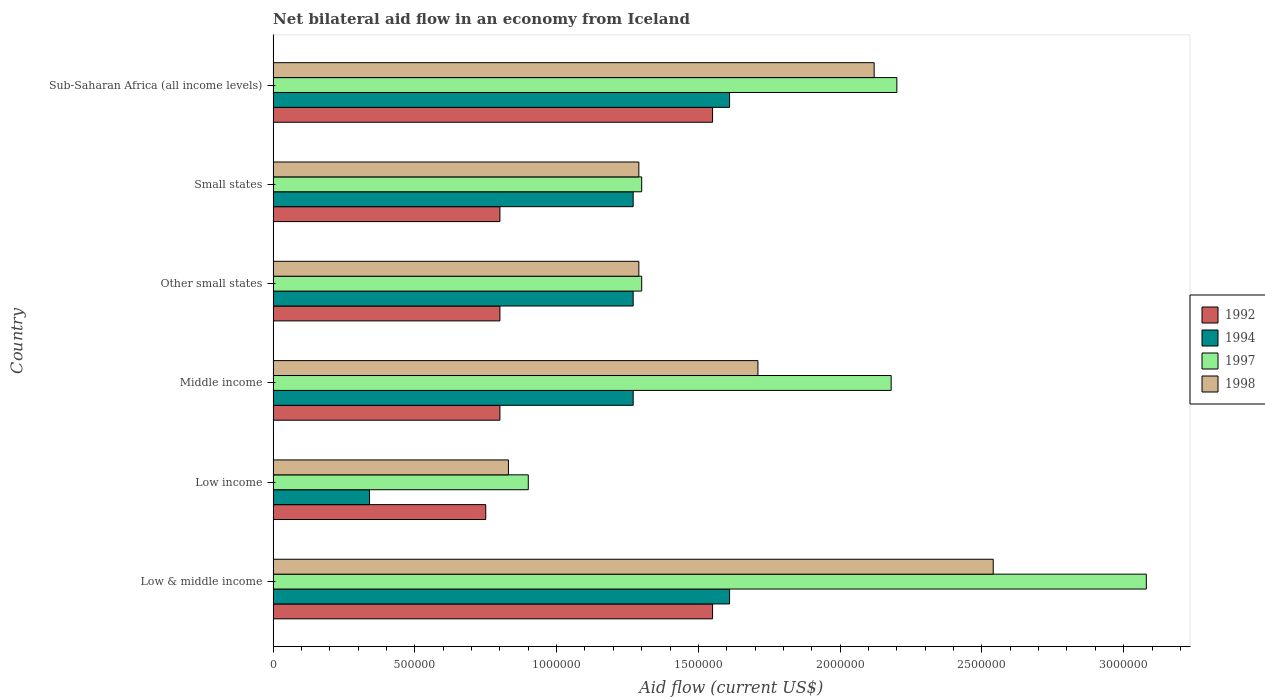How many bars are there on the 3rd tick from the top?
Your response must be concise. 4. How many bars are there on the 2nd tick from the bottom?
Make the answer very short. 4. What is the label of the 6th group of bars from the top?
Your response must be concise. Low & middle income. What is the net bilateral aid flow in 1998 in Low income?
Provide a succinct answer. 8.30e+05. Across all countries, what is the maximum net bilateral aid flow in 1998?
Give a very brief answer. 2.54e+06. In which country was the net bilateral aid flow in 1992 minimum?
Provide a short and direct response. Low income. What is the total net bilateral aid flow in 1997 in the graph?
Provide a short and direct response. 1.10e+07. What is the difference between the net bilateral aid flow in 1994 in Low & middle income and that in Other small states?
Give a very brief answer. 3.40e+05. What is the difference between the net bilateral aid flow in 1998 in Other small states and the net bilateral aid flow in 1994 in Low income?
Offer a very short reply. 9.50e+05. What is the average net bilateral aid flow in 1998 per country?
Keep it short and to the point. 1.63e+06. What is the difference between the net bilateral aid flow in 1998 and net bilateral aid flow in 1992 in Sub-Saharan Africa (all income levels)?
Offer a terse response. 5.70e+05. In how many countries, is the net bilateral aid flow in 1992 greater than 500000 US$?
Keep it short and to the point. 6. Is the net bilateral aid flow in 1994 in Low income less than that in Other small states?
Your answer should be compact. Yes. Is the difference between the net bilateral aid flow in 1998 in Low income and Other small states greater than the difference between the net bilateral aid flow in 1992 in Low income and Other small states?
Keep it short and to the point. No. What is the difference between the highest and the second highest net bilateral aid flow in 1998?
Provide a short and direct response. 4.20e+05. What is the difference between the highest and the lowest net bilateral aid flow in 1998?
Provide a short and direct response. 1.71e+06. In how many countries, is the net bilateral aid flow in 1998 greater than the average net bilateral aid flow in 1998 taken over all countries?
Offer a very short reply. 3. Is the sum of the net bilateral aid flow in 1998 in Low income and Sub-Saharan Africa (all income levels) greater than the maximum net bilateral aid flow in 1994 across all countries?
Provide a succinct answer. Yes. Is it the case that in every country, the sum of the net bilateral aid flow in 1994 and net bilateral aid flow in 1997 is greater than the sum of net bilateral aid flow in 1992 and net bilateral aid flow in 1998?
Your answer should be compact. No. What does the 1st bar from the bottom in Low & middle income represents?
Make the answer very short. 1992. Is it the case that in every country, the sum of the net bilateral aid flow in 1994 and net bilateral aid flow in 1992 is greater than the net bilateral aid flow in 1997?
Offer a very short reply. No. How many bars are there?
Your answer should be compact. 24. Are all the bars in the graph horizontal?
Make the answer very short. Yes. Are the values on the major ticks of X-axis written in scientific E-notation?
Make the answer very short. No. Does the graph contain any zero values?
Your response must be concise. No. Where does the legend appear in the graph?
Give a very brief answer. Center right. How many legend labels are there?
Your answer should be very brief. 4. How are the legend labels stacked?
Provide a short and direct response. Vertical. What is the title of the graph?
Keep it short and to the point. Net bilateral aid flow in an economy from Iceland. Does "2007" appear as one of the legend labels in the graph?
Your response must be concise. No. What is the label or title of the Y-axis?
Your response must be concise. Country. What is the Aid flow (current US$) of 1992 in Low & middle income?
Your answer should be compact. 1.55e+06. What is the Aid flow (current US$) of 1994 in Low & middle income?
Offer a very short reply. 1.61e+06. What is the Aid flow (current US$) in 1997 in Low & middle income?
Your answer should be compact. 3.08e+06. What is the Aid flow (current US$) in 1998 in Low & middle income?
Give a very brief answer. 2.54e+06. What is the Aid flow (current US$) in 1992 in Low income?
Your response must be concise. 7.50e+05. What is the Aid flow (current US$) of 1998 in Low income?
Provide a short and direct response. 8.30e+05. What is the Aid flow (current US$) of 1994 in Middle income?
Offer a very short reply. 1.27e+06. What is the Aid flow (current US$) of 1997 in Middle income?
Provide a short and direct response. 2.18e+06. What is the Aid flow (current US$) of 1998 in Middle income?
Offer a very short reply. 1.71e+06. What is the Aid flow (current US$) in 1994 in Other small states?
Offer a very short reply. 1.27e+06. What is the Aid flow (current US$) in 1997 in Other small states?
Your answer should be compact. 1.30e+06. What is the Aid flow (current US$) of 1998 in Other small states?
Offer a terse response. 1.29e+06. What is the Aid flow (current US$) of 1994 in Small states?
Offer a terse response. 1.27e+06. What is the Aid flow (current US$) of 1997 in Small states?
Keep it short and to the point. 1.30e+06. What is the Aid flow (current US$) in 1998 in Small states?
Give a very brief answer. 1.29e+06. What is the Aid flow (current US$) in 1992 in Sub-Saharan Africa (all income levels)?
Your answer should be compact. 1.55e+06. What is the Aid flow (current US$) of 1994 in Sub-Saharan Africa (all income levels)?
Keep it short and to the point. 1.61e+06. What is the Aid flow (current US$) in 1997 in Sub-Saharan Africa (all income levels)?
Provide a short and direct response. 2.20e+06. What is the Aid flow (current US$) in 1998 in Sub-Saharan Africa (all income levels)?
Your answer should be very brief. 2.12e+06. Across all countries, what is the maximum Aid flow (current US$) of 1992?
Provide a short and direct response. 1.55e+06. Across all countries, what is the maximum Aid flow (current US$) of 1994?
Provide a succinct answer. 1.61e+06. Across all countries, what is the maximum Aid flow (current US$) of 1997?
Offer a very short reply. 3.08e+06. Across all countries, what is the maximum Aid flow (current US$) of 1998?
Your answer should be very brief. 2.54e+06. Across all countries, what is the minimum Aid flow (current US$) in 1992?
Make the answer very short. 7.50e+05. Across all countries, what is the minimum Aid flow (current US$) in 1994?
Your answer should be compact. 3.40e+05. Across all countries, what is the minimum Aid flow (current US$) of 1998?
Keep it short and to the point. 8.30e+05. What is the total Aid flow (current US$) in 1992 in the graph?
Your answer should be very brief. 6.25e+06. What is the total Aid flow (current US$) in 1994 in the graph?
Ensure brevity in your answer.  7.37e+06. What is the total Aid flow (current US$) of 1997 in the graph?
Your answer should be very brief. 1.10e+07. What is the total Aid flow (current US$) in 1998 in the graph?
Provide a short and direct response. 9.78e+06. What is the difference between the Aid flow (current US$) in 1994 in Low & middle income and that in Low income?
Your response must be concise. 1.27e+06. What is the difference between the Aid flow (current US$) of 1997 in Low & middle income and that in Low income?
Your response must be concise. 2.18e+06. What is the difference between the Aid flow (current US$) of 1998 in Low & middle income and that in Low income?
Ensure brevity in your answer.  1.71e+06. What is the difference between the Aid flow (current US$) in 1992 in Low & middle income and that in Middle income?
Your answer should be compact. 7.50e+05. What is the difference between the Aid flow (current US$) in 1998 in Low & middle income and that in Middle income?
Give a very brief answer. 8.30e+05. What is the difference between the Aid flow (current US$) in 1992 in Low & middle income and that in Other small states?
Provide a short and direct response. 7.50e+05. What is the difference between the Aid flow (current US$) of 1997 in Low & middle income and that in Other small states?
Your answer should be very brief. 1.78e+06. What is the difference between the Aid flow (current US$) in 1998 in Low & middle income and that in Other small states?
Your response must be concise. 1.25e+06. What is the difference between the Aid flow (current US$) in 1992 in Low & middle income and that in Small states?
Give a very brief answer. 7.50e+05. What is the difference between the Aid flow (current US$) of 1997 in Low & middle income and that in Small states?
Provide a short and direct response. 1.78e+06. What is the difference between the Aid flow (current US$) in 1998 in Low & middle income and that in Small states?
Your answer should be very brief. 1.25e+06. What is the difference between the Aid flow (current US$) in 1994 in Low & middle income and that in Sub-Saharan Africa (all income levels)?
Give a very brief answer. 0. What is the difference between the Aid flow (current US$) in 1997 in Low & middle income and that in Sub-Saharan Africa (all income levels)?
Provide a succinct answer. 8.80e+05. What is the difference between the Aid flow (current US$) of 1994 in Low income and that in Middle income?
Offer a very short reply. -9.30e+05. What is the difference between the Aid flow (current US$) in 1997 in Low income and that in Middle income?
Your response must be concise. -1.28e+06. What is the difference between the Aid flow (current US$) of 1998 in Low income and that in Middle income?
Give a very brief answer. -8.80e+05. What is the difference between the Aid flow (current US$) in 1992 in Low income and that in Other small states?
Make the answer very short. -5.00e+04. What is the difference between the Aid flow (current US$) of 1994 in Low income and that in Other small states?
Your answer should be compact. -9.30e+05. What is the difference between the Aid flow (current US$) in 1997 in Low income and that in Other small states?
Make the answer very short. -4.00e+05. What is the difference between the Aid flow (current US$) in 1998 in Low income and that in Other small states?
Keep it short and to the point. -4.60e+05. What is the difference between the Aid flow (current US$) in 1994 in Low income and that in Small states?
Provide a succinct answer. -9.30e+05. What is the difference between the Aid flow (current US$) of 1997 in Low income and that in Small states?
Provide a succinct answer. -4.00e+05. What is the difference between the Aid flow (current US$) of 1998 in Low income and that in Small states?
Your answer should be compact. -4.60e+05. What is the difference between the Aid flow (current US$) in 1992 in Low income and that in Sub-Saharan Africa (all income levels)?
Provide a short and direct response. -8.00e+05. What is the difference between the Aid flow (current US$) in 1994 in Low income and that in Sub-Saharan Africa (all income levels)?
Your answer should be compact. -1.27e+06. What is the difference between the Aid flow (current US$) in 1997 in Low income and that in Sub-Saharan Africa (all income levels)?
Offer a very short reply. -1.30e+06. What is the difference between the Aid flow (current US$) of 1998 in Low income and that in Sub-Saharan Africa (all income levels)?
Offer a very short reply. -1.29e+06. What is the difference between the Aid flow (current US$) of 1992 in Middle income and that in Other small states?
Provide a succinct answer. 0. What is the difference between the Aid flow (current US$) in 1997 in Middle income and that in Other small states?
Ensure brevity in your answer.  8.80e+05. What is the difference between the Aid flow (current US$) in 1997 in Middle income and that in Small states?
Provide a short and direct response. 8.80e+05. What is the difference between the Aid flow (current US$) of 1992 in Middle income and that in Sub-Saharan Africa (all income levels)?
Offer a terse response. -7.50e+05. What is the difference between the Aid flow (current US$) in 1998 in Middle income and that in Sub-Saharan Africa (all income levels)?
Make the answer very short. -4.10e+05. What is the difference between the Aid flow (current US$) in 1994 in Other small states and that in Small states?
Provide a short and direct response. 0. What is the difference between the Aid flow (current US$) of 1997 in Other small states and that in Small states?
Offer a very short reply. 0. What is the difference between the Aid flow (current US$) of 1992 in Other small states and that in Sub-Saharan Africa (all income levels)?
Offer a terse response. -7.50e+05. What is the difference between the Aid flow (current US$) in 1997 in Other small states and that in Sub-Saharan Africa (all income levels)?
Your answer should be very brief. -9.00e+05. What is the difference between the Aid flow (current US$) of 1998 in Other small states and that in Sub-Saharan Africa (all income levels)?
Make the answer very short. -8.30e+05. What is the difference between the Aid flow (current US$) in 1992 in Small states and that in Sub-Saharan Africa (all income levels)?
Give a very brief answer. -7.50e+05. What is the difference between the Aid flow (current US$) of 1997 in Small states and that in Sub-Saharan Africa (all income levels)?
Provide a short and direct response. -9.00e+05. What is the difference between the Aid flow (current US$) in 1998 in Small states and that in Sub-Saharan Africa (all income levels)?
Ensure brevity in your answer.  -8.30e+05. What is the difference between the Aid flow (current US$) in 1992 in Low & middle income and the Aid flow (current US$) in 1994 in Low income?
Make the answer very short. 1.21e+06. What is the difference between the Aid flow (current US$) of 1992 in Low & middle income and the Aid flow (current US$) of 1997 in Low income?
Give a very brief answer. 6.50e+05. What is the difference between the Aid flow (current US$) in 1992 in Low & middle income and the Aid flow (current US$) in 1998 in Low income?
Make the answer very short. 7.20e+05. What is the difference between the Aid flow (current US$) of 1994 in Low & middle income and the Aid flow (current US$) of 1997 in Low income?
Make the answer very short. 7.10e+05. What is the difference between the Aid flow (current US$) in 1994 in Low & middle income and the Aid flow (current US$) in 1998 in Low income?
Provide a succinct answer. 7.80e+05. What is the difference between the Aid flow (current US$) in 1997 in Low & middle income and the Aid flow (current US$) in 1998 in Low income?
Offer a terse response. 2.25e+06. What is the difference between the Aid flow (current US$) in 1992 in Low & middle income and the Aid flow (current US$) in 1997 in Middle income?
Your answer should be compact. -6.30e+05. What is the difference between the Aid flow (current US$) in 1994 in Low & middle income and the Aid flow (current US$) in 1997 in Middle income?
Your answer should be very brief. -5.70e+05. What is the difference between the Aid flow (current US$) in 1997 in Low & middle income and the Aid flow (current US$) in 1998 in Middle income?
Your answer should be compact. 1.37e+06. What is the difference between the Aid flow (current US$) in 1992 in Low & middle income and the Aid flow (current US$) in 1997 in Other small states?
Keep it short and to the point. 2.50e+05. What is the difference between the Aid flow (current US$) of 1992 in Low & middle income and the Aid flow (current US$) of 1998 in Other small states?
Provide a succinct answer. 2.60e+05. What is the difference between the Aid flow (current US$) of 1994 in Low & middle income and the Aid flow (current US$) of 1997 in Other small states?
Ensure brevity in your answer.  3.10e+05. What is the difference between the Aid flow (current US$) of 1997 in Low & middle income and the Aid flow (current US$) of 1998 in Other small states?
Your answer should be very brief. 1.79e+06. What is the difference between the Aid flow (current US$) of 1992 in Low & middle income and the Aid flow (current US$) of 1994 in Small states?
Provide a succinct answer. 2.80e+05. What is the difference between the Aid flow (current US$) of 1992 in Low & middle income and the Aid flow (current US$) of 1997 in Small states?
Offer a terse response. 2.50e+05. What is the difference between the Aid flow (current US$) of 1992 in Low & middle income and the Aid flow (current US$) of 1998 in Small states?
Provide a succinct answer. 2.60e+05. What is the difference between the Aid flow (current US$) of 1994 in Low & middle income and the Aid flow (current US$) of 1997 in Small states?
Give a very brief answer. 3.10e+05. What is the difference between the Aid flow (current US$) in 1994 in Low & middle income and the Aid flow (current US$) in 1998 in Small states?
Your response must be concise. 3.20e+05. What is the difference between the Aid flow (current US$) of 1997 in Low & middle income and the Aid flow (current US$) of 1998 in Small states?
Your response must be concise. 1.79e+06. What is the difference between the Aid flow (current US$) of 1992 in Low & middle income and the Aid flow (current US$) of 1994 in Sub-Saharan Africa (all income levels)?
Give a very brief answer. -6.00e+04. What is the difference between the Aid flow (current US$) in 1992 in Low & middle income and the Aid flow (current US$) in 1997 in Sub-Saharan Africa (all income levels)?
Give a very brief answer. -6.50e+05. What is the difference between the Aid flow (current US$) in 1992 in Low & middle income and the Aid flow (current US$) in 1998 in Sub-Saharan Africa (all income levels)?
Keep it short and to the point. -5.70e+05. What is the difference between the Aid flow (current US$) of 1994 in Low & middle income and the Aid flow (current US$) of 1997 in Sub-Saharan Africa (all income levels)?
Your answer should be compact. -5.90e+05. What is the difference between the Aid flow (current US$) of 1994 in Low & middle income and the Aid flow (current US$) of 1998 in Sub-Saharan Africa (all income levels)?
Your answer should be very brief. -5.10e+05. What is the difference between the Aid flow (current US$) of 1997 in Low & middle income and the Aid flow (current US$) of 1998 in Sub-Saharan Africa (all income levels)?
Offer a terse response. 9.60e+05. What is the difference between the Aid flow (current US$) in 1992 in Low income and the Aid flow (current US$) in 1994 in Middle income?
Ensure brevity in your answer.  -5.20e+05. What is the difference between the Aid flow (current US$) of 1992 in Low income and the Aid flow (current US$) of 1997 in Middle income?
Provide a short and direct response. -1.43e+06. What is the difference between the Aid flow (current US$) in 1992 in Low income and the Aid flow (current US$) in 1998 in Middle income?
Offer a very short reply. -9.60e+05. What is the difference between the Aid flow (current US$) in 1994 in Low income and the Aid flow (current US$) in 1997 in Middle income?
Offer a terse response. -1.84e+06. What is the difference between the Aid flow (current US$) in 1994 in Low income and the Aid flow (current US$) in 1998 in Middle income?
Provide a succinct answer. -1.37e+06. What is the difference between the Aid flow (current US$) of 1997 in Low income and the Aid flow (current US$) of 1998 in Middle income?
Your response must be concise. -8.10e+05. What is the difference between the Aid flow (current US$) of 1992 in Low income and the Aid flow (current US$) of 1994 in Other small states?
Your response must be concise. -5.20e+05. What is the difference between the Aid flow (current US$) of 1992 in Low income and the Aid flow (current US$) of 1997 in Other small states?
Make the answer very short. -5.50e+05. What is the difference between the Aid flow (current US$) of 1992 in Low income and the Aid flow (current US$) of 1998 in Other small states?
Ensure brevity in your answer.  -5.40e+05. What is the difference between the Aid flow (current US$) in 1994 in Low income and the Aid flow (current US$) in 1997 in Other small states?
Provide a succinct answer. -9.60e+05. What is the difference between the Aid flow (current US$) of 1994 in Low income and the Aid flow (current US$) of 1998 in Other small states?
Your answer should be compact. -9.50e+05. What is the difference between the Aid flow (current US$) of 1997 in Low income and the Aid flow (current US$) of 1998 in Other small states?
Offer a terse response. -3.90e+05. What is the difference between the Aid flow (current US$) in 1992 in Low income and the Aid flow (current US$) in 1994 in Small states?
Your answer should be compact. -5.20e+05. What is the difference between the Aid flow (current US$) of 1992 in Low income and the Aid flow (current US$) of 1997 in Small states?
Your answer should be compact. -5.50e+05. What is the difference between the Aid flow (current US$) of 1992 in Low income and the Aid flow (current US$) of 1998 in Small states?
Make the answer very short. -5.40e+05. What is the difference between the Aid flow (current US$) of 1994 in Low income and the Aid flow (current US$) of 1997 in Small states?
Provide a succinct answer. -9.60e+05. What is the difference between the Aid flow (current US$) in 1994 in Low income and the Aid flow (current US$) in 1998 in Small states?
Offer a terse response. -9.50e+05. What is the difference between the Aid flow (current US$) of 1997 in Low income and the Aid flow (current US$) of 1998 in Small states?
Your answer should be very brief. -3.90e+05. What is the difference between the Aid flow (current US$) in 1992 in Low income and the Aid flow (current US$) in 1994 in Sub-Saharan Africa (all income levels)?
Keep it short and to the point. -8.60e+05. What is the difference between the Aid flow (current US$) of 1992 in Low income and the Aid flow (current US$) of 1997 in Sub-Saharan Africa (all income levels)?
Your answer should be compact. -1.45e+06. What is the difference between the Aid flow (current US$) of 1992 in Low income and the Aid flow (current US$) of 1998 in Sub-Saharan Africa (all income levels)?
Provide a succinct answer. -1.37e+06. What is the difference between the Aid flow (current US$) in 1994 in Low income and the Aid flow (current US$) in 1997 in Sub-Saharan Africa (all income levels)?
Provide a short and direct response. -1.86e+06. What is the difference between the Aid flow (current US$) of 1994 in Low income and the Aid flow (current US$) of 1998 in Sub-Saharan Africa (all income levels)?
Ensure brevity in your answer.  -1.78e+06. What is the difference between the Aid flow (current US$) in 1997 in Low income and the Aid flow (current US$) in 1998 in Sub-Saharan Africa (all income levels)?
Your response must be concise. -1.22e+06. What is the difference between the Aid flow (current US$) of 1992 in Middle income and the Aid flow (current US$) of 1994 in Other small states?
Make the answer very short. -4.70e+05. What is the difference between the Aid flow (current US$) in 1992 in Middle income and the Aid flow (current US$) in 1997 in Other small states?
Provide a succinct answer. -5.00e+05. What is the difference between the Aid flow (current US$) of 1992 in Middle income and the Aid flow (current US$) of 1998 in Other small states?
Provide a succinct answer. -4.90e+05. What is the difference between the Aid flow (current US$) of 1994 in Middle income and the Aid flow (current US$) of 1997 in Other small states?
Your response must be concise. -3.00e+04. What is the difference between the Aid flow (current US$) of 1994 in Middle income and the Aid flow (current US$) of 1998 in Other small states?
Ensure brevity in your answer.  -2.00e+04. What is the difference between the Aid flow (current US$) in 1997 in Middle income and the Aid flow (current US$) in 1998 in Other small states?
Give a very brief answer. 8.90e+05. What is the difference between the Aid flow (current US$) of 1992 in Middle income and the Aid flow (current US$) of 1994 in Small states?
Provide a succinct answer. -4.70e+05. What is the difference between the Aid flow (current US$) in 1992 in Middle income and the Aid flow (current US$) in 1997 in Small states?
Keep it short and to the point. -5.00e+05. What is the difference between the Aid flow (current US$) of 1992 in Middle income and the Aid flow (current US$) of 1998 in Small states?
Your answer should be compact. -4.90e+05. What is the difference between the Aid flow (current US$) of 1994 in Middle income and the Aid flow (current US$) of 1997 in Small states?
Give a very brief answer. -3.00e+04. What is the difference between the Aid flow (current US$) in 1994 in Middle income and the Aid flow (current US$) in 1998 in Small states?
Offer a terse response. -2.00e+04. What is the difference between the Aid flow (current US$) of 1997 in Middle income and the Aid flow (current US$) of 1998 in Small states?
Make the answer very short. 8.90e+05. What is the difference between the Aid flow (current US$) in 1992 in Middle income and the Aid flow (current US$) in 1994 in Sub-Saharan Africa (all income levels)?
Provide a short and direct response. -8.10e+05. What is the difference between the Aid flow (current US$) of 1992 in Middle income and the Aid flow (current US$) of 1997 in Sub-Saharan Africa (all income levels)?
Offer a very short reply. -1.40e+06. What is the difference between the Aid flow (current US$) in 1992 in Middle income and the Aid flow (current US$) in 1998 in Sub-Saharan Africa (all income levels)?
Provide a short and direct response. -1.32e+06. What is the difference between the Aid flow (current US$) of 1994 in Middle income and the Aid flow (current US$) of 1997 in Sub-Saharan Africa (all income levels)?
Offer a terse response. -9.30e+05. What is the difference between the Aid flow (current US$) in 1994 in Middle income and the Aid flow (current US$) in 1998 in Sub-Saharan Africa (all income levels)?
Your answer should be very brief. -8.50e+05. What is the difference between the Aid flow (current US$) of 1992 in Other small states and the Aid flow (current US$) of 1994 in Small states?
Your answer should be very brief. -4.70e+05. What is the difference between the Aid flow (current US$) in 1992 in Other small states and the Aid flow (current US$) in 1997 in Small states?
Make the answer very short. -5.00e+05. What is the difference between the Aid flow (current US$) in 1992 in Other small states and the Aid flow (current US$) in 1998 in Small states?
Your answer should be compact. -4.90e+05. What is the difference between the Aid flow (current US$) in 1994 in Other small states and the Aid flow (current US$) in 1997 in Small states?
Your response must be concise. -3.00e+04. What is the difference between the Aid flow (current US$) of 1997 in Other small states and the Aid flow (current US$) of 1998 in Small states?
Offer a very short reply. 10000. What is the difference between the Aid flow (current US$) of 1992 in Other small states and the Aid flow (current US$) of 1994 in Sub-Saharan Africa (all income levels)?
Your answer should be compact. -8.10e+05. What is the difference between the Aid flow (current US$) of 1992 in Other small states and the Aid flow (current US$) of 1997 in Sub-Saharan Africa (all income levels)?
Make the answer very short. -1.40e+06. What is the difference between the Aid flow (current US$) of 1992 in Other small states and the Aid flow (current US$) of 1998 in Sub-Saharan Africa (all income levels)?
Ensure brevity in your answer.  -1.32e+06. What is the difference between the Aid flow (current US$) in 1994 in Other small states and the Aid flow (current US$) in 1997 in Sub-Saharan Africa (all income levels)?
Provide a short and direct response. -9.30e+05. What is the difference between the Aid flow (current US$) of 1994 in Other small states and the Aid flow (current US$) of 1998 in Sub-Saharan Africa (all income levels)?
Make the answer very short. -8.50e+05. What is the difference between the Aid flow (current US$) in 1997 in Other small states and the Aid flow (current US$) in 1998 in Sub-Saharan Africa (all income levels)?
Provide a short and direct response. -8.20e+05. What is the difference between the Aid flow (current US$) in 1992 in Small states and the Aid flow (current US$) in 1994 in Sub-Saharan Africa (all income levels)?
Provide a short and direct response. -8.10e+05. What is the difference between the Aid flow (current US$) of 1992 in Small states and the Aid flow (current US$) of 1997 in Sub-Saharan Africa (all income levels)?
Your response must be concise. -1.40e+06. What is the difference between the Aid flow (current US$) in 1992 in Small states and the Aid flow (current US$) in 1998 in Sub-Saharan Africa (all income levels)?
Make the answer very short. -1.32e+06. What is the difference between the Aid flow (current US$) of 1994 in Small states and the Aid flow (current US$) of 1997 in Sub-Saharan Africa (all income levels)?
Make the answer very short. -9.30e+05. What is the difference between the Aid flow (current US$) of 1994 in Small states and the Aid flow (current US$) of 1998 in Sub-Saharan Africa (all income levels)?
Keep it short and to the point. -8.50e+05. What is the difference between the Aid flow (current US$) in 1997 in Small states and the Aid flow (current US$) in 1998 in Sub-Saharan Africa (all income levels)?
Your response must be concise. -8.20e+05. What is the average Aid flow (current US$) of 1992 per country?
Ensure brevity in your answer.  1.04e+06. What is the average Aid flow (current US$) of 1994 per country?
Provide a succinct answer. 1.23e+06. What is the average Aid flow (current US$) of 1997 per country?
Your answer should be very brief. 1.83e+06. What is the average Aid flow (current US$) of 1998 per country?
Give a very brief answer. 1.63e+06. What is the difference between the Aid flow (current US$) of 1992 and Aid flow (current US$) of 1997 in Low & middle income?
Your answer should be very brief. -1.53e+06. What is the difference between the Aid flow (current US$) in 1992 and Aid flow (current US$) in 1998 in Low & middle income?
Your answer should be compact. -9.90e+05. What is the difference between the Aid flow (current US$) of 1994 and Aid flow (current US$) of 1997 in Low & middle income?
Your answer should be very brief. -1.47e+06. What is the difference between the Aid flow (current US$) of 1994 and Aid flow (current US$) of 1998 in Low & middle income?
Provide a short and direct response. -9.30e+05. What is the difference between the Aid flow (current US$) of 1997 and Aid flow (current US$) of 1998 in Low & middle income?
Make the answer very short. 5.40e+05. What is the difference between the Aid flow (current US$) of 1992 and Aid flow (current US$) of 1997 in Low income?
Your response must be concise. -1.50e+05. What is the difference between the Aid flow (current US$) in 1992 and Aid flow (current US$) in 1998 in Low income?
Your answer should be compact. -8.00e+04. What is the difference between the Aid flow (current US$) of 1994 and Aid flow (current US$) of 1997 in Low income?
Your answer should be compact. -5.60e+05. What is the difference between the Aid flow (current US$) of 1994 and Aid flow (current US$) of 1998 in Low income?
Your answer should be very brief. -4.90e+05. What is the difference between the Aid flow (current US$) of 1992 and Aid flow (current US$) of 1994 in Middle income?
Give a very brief answer. -4.70e+05. What is the difference between the Aid flow (current US$) of 1992 and Aid flow (current US$) of 1997 in Middle income?
Make the answer very short. -1.38e+06. What is the difference between the Aid flow (current US$) of 1992 and Aid flow (current US$) of 1998 in Middle income?
Your answer should be compact. -9.10e+05. What is the difference between the Aid flow (current US$) of 1994 and Aid flow (current US$) of 1997 in Middle income?
Ensure brevity in your answer.  -9.10e+05. What is the difference between the Aid flow (current US$) of 1994 and Aid flow (current US$) of 1998 in Middle income?
Offer a very short reply. -4.40e+05. What is the difference between the Aid flow (current US$) of 1997 and Aid flow (current US$) of 1998 in Middle income?
Provide a short and direct response. 4.70e+05. What is the difference between the Aid flow (current US$) of 1992 and Aid flow (current US$) of 1994 in Other small states?
Give a very brief answer. -4.70e+05. What is the difference between the Aid flow (current US$) in 1992 and Aid flow (current US$) in 1997 in Other small states?
Your answer should be very brief. -5.00e+05. What is the difference between the Aid flow (current US$) in 1992 and Aid flow (current US$) in 1998 in Other small states?
Make the answer very short. -4.90e+05. What is the difference between the Aid flow (current US$) in 1994 and Aid flow (current US$) in 1998 in Other small states?
Give a very brief answer. -2.00e+04. What is the difference between the Aid flow (current US$) of 1997 and Aid flow (current US$) of 1998 in Other small states?
Provide a short and direct response. 10000. What is the difference between the Aid flow (current US$) of 1992 and Aid flow (current US$) of 1994 in Small states?
Provide a succinct answer. -4.70e+05. What is the difference between the Aid flow (current US$) of 1992 and Aid flow (current US$) of 1997 in Small states?
Your answer should be compact. -5.00e+05. What is the difference between the Aid flow (current US$) of 1992 and Aid flow (current US$) of 1998 in Small states?
Make the answer very short. -4.90e+05. What is the difference between the Aid flow (current US$) of 1997 and Aid flow (current US$) of 1998 in Small states?
Provide a succinct answer. 10000. What is the difference between the Aid flow (current US$) in 1992 and Aid flow (current US$) in 1997 in Sub-Saharan Africa (all income levels)?
Make the answer very short. -6.50e+05. What is the difference between the Aid flow (current US$) of 1992 and Aid flow (current US$) of 1998 in Sub-Saharan Africa (all income levels)?
Ensure brevity in your answer.  -5.70e+05. What is the difference between the Aid flow (current US$) of 1994 and Aid flow (current US$) of 1997 in Sub-Saharan Africa (all income levels)?
Your answer should be very brief. -5.90e+05. What is the difference between the Aid flow (current US$) of 1994 and Aid flow (current US$) of 1998 in Sub-Saharan Africa (all income levels)?
Ensure brevity in your answer.  -5.10e+05. What is the difference between the Aid flow (current US$) in 1997 and Aid flow (current US$) in 1998 in Sub-Saharan Africa (all income levels)?
Keep it short and to the point. 8.00e+04. What is the ratio of the Aid flow (current US$) of 1992 in Low & middle income to that in Low income?
Your response must be concise. 2.07. What is the ratio of the Aid flow (current US$) in 1994 in Low & middle income to that in Low income?
Your response must be concise. 4.74. What is the ratio of the Aid flow (current US$) in 1997 in Low & middle income to that in Low income?
Your answer should be compact. 3.42. What is the ratio of the Aid flow (current US$) of 1998 in Low & middle income to that in Low income?
Offer a very short reply. 3.06. What is the ratio of the Aid flow (current US$) in 1992 in Low & middle income to that in Middle income?
Provide a succinct answer. 1.94. What is the ratio of the Aid flow (current US$) of 1994 in Low & middle income to that in Middle income?
Your response must be concise. 1.27. What is the ratio of the Aid flow (current US$) in 1997 in Low & middle income to that in Middle income?
Ensure brevity in your answer.  1.41. What is the ratio of the Aid flow (current US$) of 1998 in Low & middle income to that in Middle income?
Your answer should be very brief. 1.49. What is the ratio of the Aid flow (current US$) in 1992 in Low & middle income to that in Other small states?
Make the answer very short. 1.94. What is the ratio of the Aid flow (current US$) in 1994 in Low & middle income to that in Other small states?
Provide a short and direct response. 1.27. What is the ratio of the Aid flow (current US$) of 1997 in Low & middle income to that in Other small states?
Keep it short and to the point. 2.37. What is the ratio of the Aid flow (current US$) of 1998 in Low & middle income to that in Other small states?
Keep it short and to the point. 1.97. What is the ratio of the Aid flow (current US$) in 1992 in Low & middle income to that in Small states?
Your response must be concise. 1.94. What is the ratio of the Aid flow (current US$) in 1994 in Low & middle income to that in Small states?
Your answer should be compact. 1.27. What is the ratio of the Aid flow (current US$) in 1997 in Low & middle income to that in Small states?
Provide a succinct answer. 2.37. What is the ratio of the Aid flow (current US$) in 1998 in Low & middle income to that in Small states?
Make the answer very short. 1.97. What is the ratio of the Aid flow (current US$) in 1994 in Low & middle income to that in Sub-Saharan Africa (all income levels)?
Your answer should be compact. 1. What is the ratio of the Aid flow (current US$) of 1998 in Low & middle income to that in Sub-Saharan Africa (all income levels)?
Give a very brief answer. 1.2. What is the ratio of the Aid flow (current US$) of 1992 in Low income to that in Middle income?
Provide a short and direct response. 0.94. What is the ratio of the Aid flow (current US$) in 1994 in Low income to that in Middle income?
Offer a terse response. 0.27. What is the ratio of the Aid flow (current US$) in 1997 in Low income to that in Middle income?
Keep it short and to the point. 0.41. What is the ratio of the Aid flow (current US$) of 1998 in Low income to that in Middle income?
Make the answer very short. 0.49. What is the ratio of the Aid flow (current US$) of 1992 in Low income to that in Other small states?
Make the answer very short. 0.94. What is the ratio of the Aid flow (current US$) in 1994 in Low income to that in Other small states?
Make the answer very short. 0.27. What is the ratio of the Aid flow (current US$) in 1997 in Low income to that in Other small states?
Provide a succinct answer. 0.69. What is the ratio of the Aid flow (current US$) in 1998 in Low income to that in Other small states?
Your answer should be very brief. 0.64. What is the ratio of the Aid flow (current US$) of 1992 in Low income to that in Small states?
Give a very brief answer. 0.94. What is the ratio of the Aid flow (current US$) of 1994 in Low income to that in Small states?
Offer a very short reply. 0.27. What is the ratio of the Aid flow (current US$) in 1997 in Low income to that in Small states?
Your response must be concise. 0.69. What is the ratio of the Aid flow (current US$) of 1998 in Low income to that in Small states?
Give a very brief answer. 0.64. What is the ratio of the Aid flow (current US$) of 1992 in Low income to that in Sub-Saharan Africa (all income levels)?
Your answer should be very brief. 0.48. What is the ratio of the Aid flow (current US$) of 1994 in Low income to that in Sub-Saharan Africa (all income levels)?
Keep it short and to the point. 0.21. What is the ratio of the Aid flow (current US$) of 1997 in Low income to that in Sub-Saharan Africa (all income levels)?
Offer a terse response. 0.41. What is the ratio of the Aid flow (current US$) in 1998 in Low income to that in Sub-Saharan Africa (all income levels)?
Keep it short and to the point. 0.39. What is the ratio of the Aid flow (current US$) of 1997 in Middle income to that in Other small states?
Your answer should be compact. 1.68. What is the ratio of the Aid flow (current US$) of 1998 in Middle income to that in Other small states?
Your answer should be very brief. 1.33. What is the ratio of the Aid flow (current US$) of 1992 in Middle income to that in Small states?
Your answer should be compact. 1. What is the ratio of the Aid flow (current US$) of 1997 in Middle income to that in Small states?
Your response must be concise. 1.68. What is the ratio of the Aid flow (current US$) in 1998 in Middle income to that in Small states?
Your answer should be compact. 1.33. What is the ratio of the Aid flow (current US$) of 1992 in Middle income to that in Sub-Saharan Africa (all income levels)?
Your answer should be compact. 0.52. What is the ratio of the Aid flow (current US$) in 1994 in Middle income to that in Sub-Saharan Africa (all income levels)?
Offer a terse response. 0.79. What is the ratio of the Aid flow (current US$) of 1997 in Middle income to that in Sub-Saharan Africa (all income levels)?
Your answer should be compact. 0.99. What is the ratio of the Aid flow (current US$) in 1998 in Middle income to that in Sub-Saharan Africa (all income levels)?
Your answer should be very brief. 0.81. What is the ratio of the Aid flow (current US$) of 1994 in Other small states to that in Small states?
Offer a terse response. 1. What is the ratio of the Aid flow (current US$) in 1997 in Other small states to that in Small states?
Provide a succinct answer. 1. What is the ratio of the Aid flow (current US$) of 1998 in Other small states to that in Small states?
Provide a short and direct response. 1. What is the ratio of the Aid flow (current US$) of 1992 in Other small states to that in Sub-Saharan Africa (all income levels)?
Ensure brevity in your answer.  0.52. What is the ratio of the Aid flow (current US$) in 1994 in Other small states to that in Sub-Saharan Africa (all income levels)?
Your answer should be very brief. 0.79. What is the ratio of the Aid flow (current US$) in 1997 in Other small states to that in Sub-Saharan Africa (all income levels)?
Keep it short and to the point. 0.59. What is the ratio of the Aid flow (current US$) of 1998 in Other small states to that in Sub-Saharan Africa (all income levels)?
Provide a short and direct response. 0.61. What is the ratio of the Aid flow (current US$) of 1992 in Small states to that in Sub-Saharan Africa (all income levels)?
Your answer should be very brief. 0.52. What is the ratio of the Aid flow (current US$) in 1994 in Small states to that in Sub-Saharan Africa (all income levels)?
Provide a short and direct response. 0.79. What is the ratio of the Aid flow (current US$) of 1997 in Small states to that in Sub-Saharan Africa (all income levels)?
Your response must be concise. 0.59. What is the ratio of the Aid flow (current US$) in 1998 in Small states to that in Sub-Saharan Africa (all income levels)?
Offer a terse response. 0.61. What is the difference between the highest and the second highest Aid flow (current US$) of 1992?
Offer a terse response. 0. What is the difference between the highest and the second highest Aid flow (current US$) of 1997?
Offer a terse response. 8.80e+05. What is the difference between the highest and the second highest Aid flow (current US$) in 1998?
Offer a very short reply. 4.20e+05. What is the difference between the highest and the lowest Aid flow (current US$) in 1992?
Your answer should be very brief. 8.00e+05. What is the difference between the highest and the lowest Aid flow (current US$) in 1994?
Ensure brevity in your answer.  1.27e+06. What is the difference between the highest and the lowest Aid flow (current US$) in 1997?
Your response must be concise. 2.18e+06. What is the difference between the highest and the lowest Aid flow (current US$) of 1998?
Your answer should be very brief. 1.71e+06. 